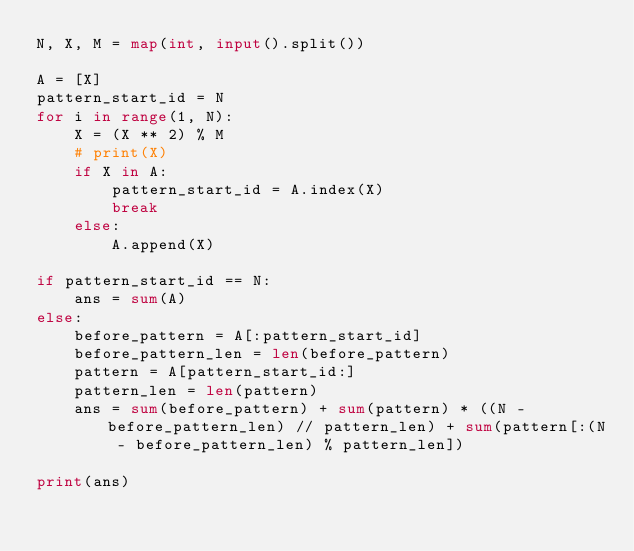Convert code to text. <code><loc_0><loc_0><loc_500><loc_500><_Python_>N, X, M = map(int, input().split())

A = [X]
pattern_start_id = N
for i in range(1, N):
    X = (X ** 2) % M
    # print(X)
    if X in A:
        pattern_start_id = A.index(X)
        break
    else:
        A.append(X)

if pattern_start_id == N:
    ans = sum(A)
else:
    before_pattern = A[:pattern_start_id]
    before_pattern_len = len(before_pattern)
    pattern = A[pattern_start_id:]
    pattern_len = len(pattern)
    ans = sum(before_pattern) + sum(pattern) * ((N - before_pattern_len) // pattern_len) + sum(pattern[:(N - before_pattern_len) % pattern_len])

print(ans)
</code> 